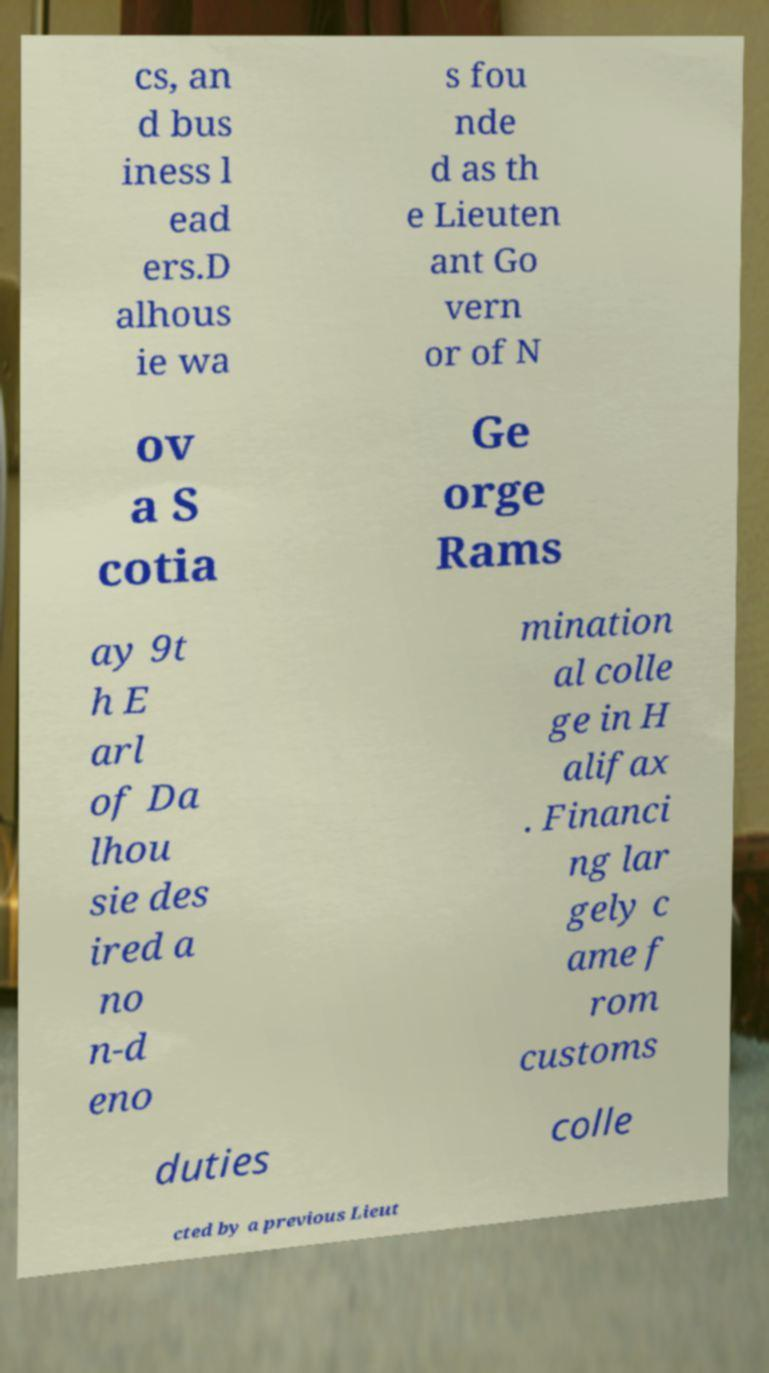I need the written content from this picture converted into text. Can you do that? cs, an d bus iness l ead ers.D alhous ie wa s fou nde d as th e Lieuten ant Go vern or of N ov a S cotia Ge orge Rams ay 9t h E arl of Da lhou sie des ired a no n-d eno mination al colle ge in H alifax . Financi ng lar gely c ame f rom customs duties colle cted by a previous Lieut 